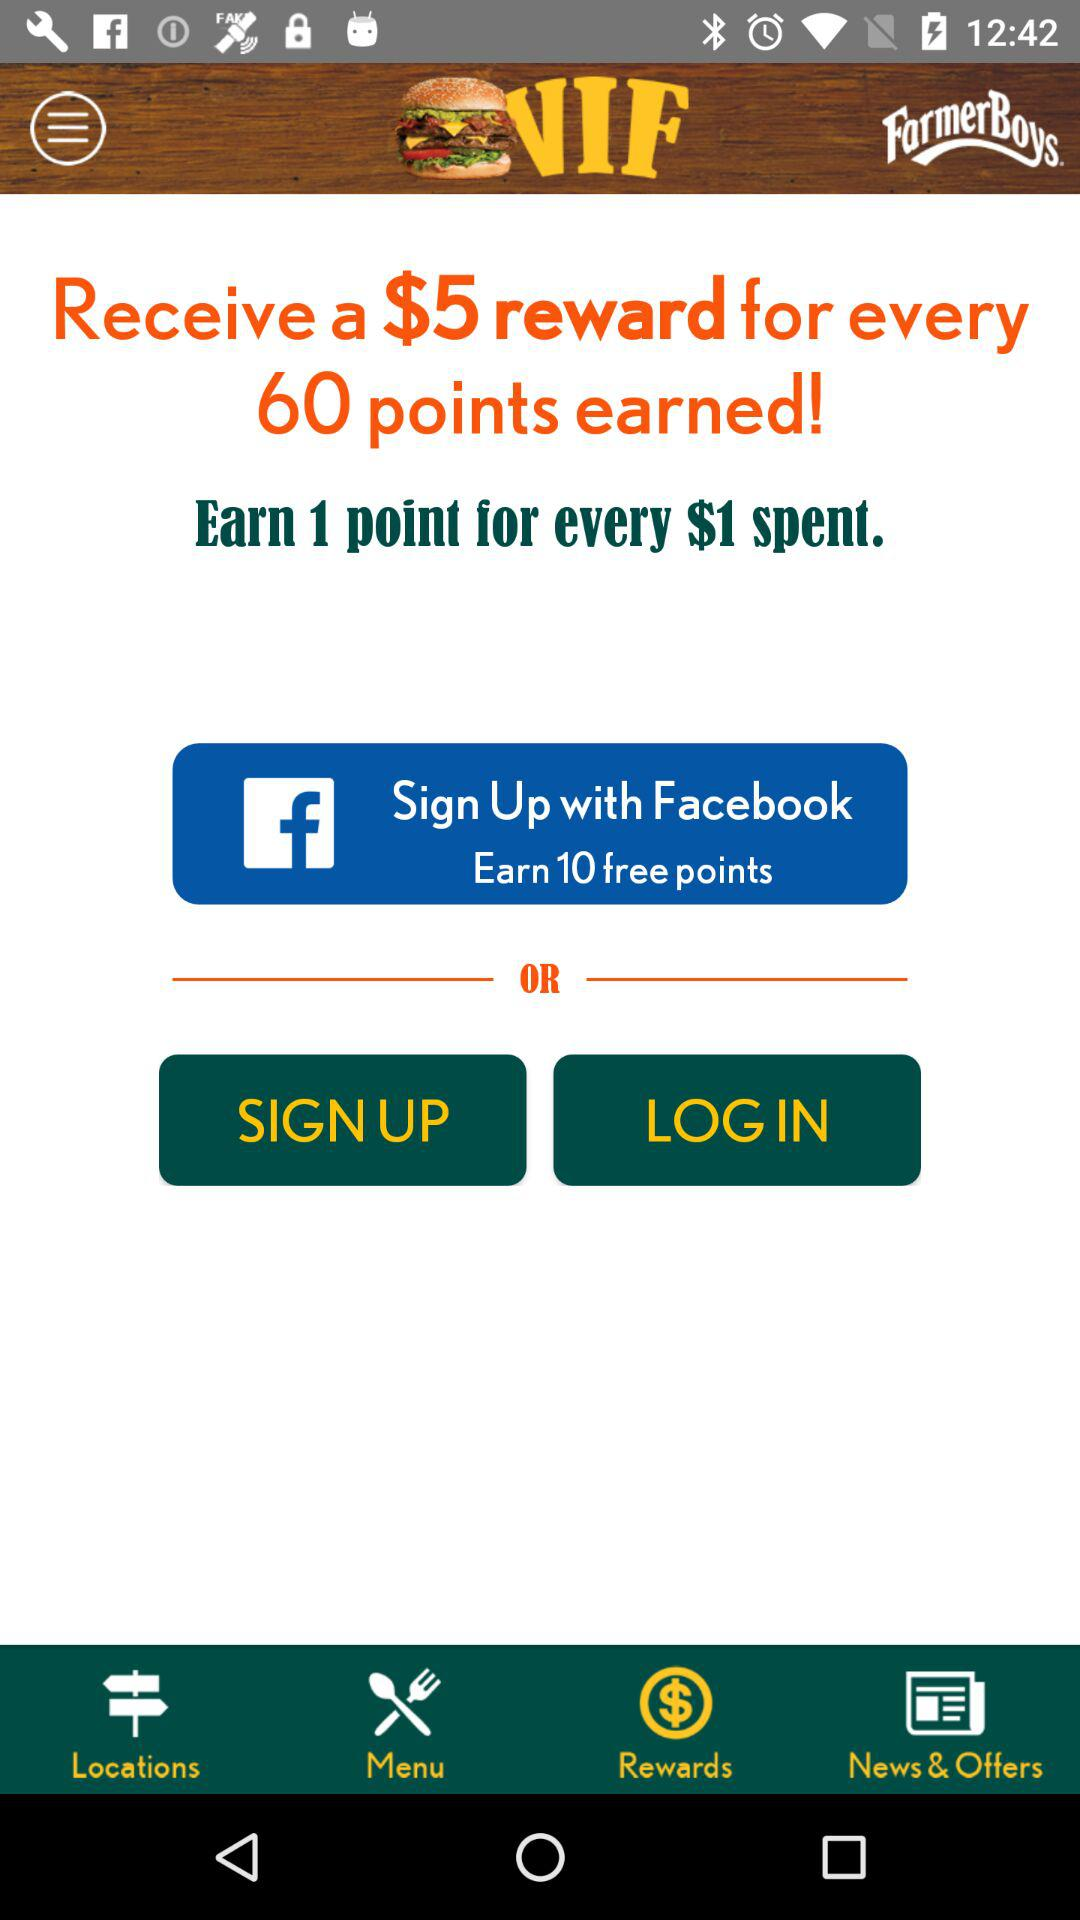How many points will the user earn for every dollar spent? The user will earn 1 point for every dollar spent. 